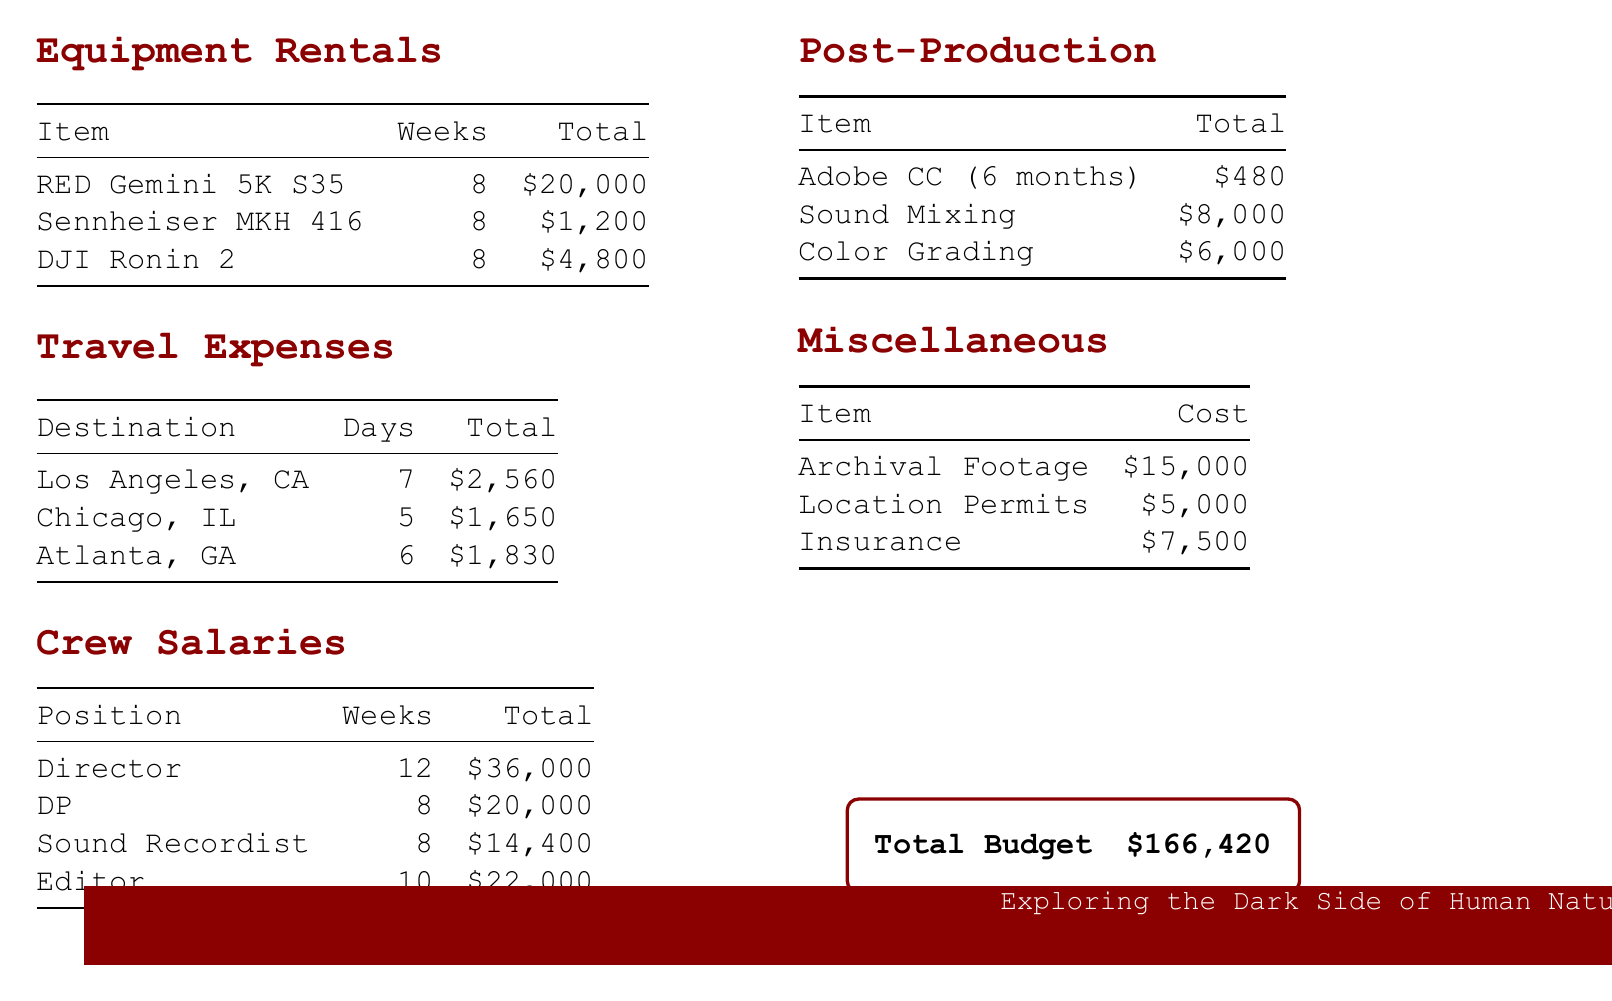what is the total budget? The total budget is located at the bottom of the document, summarizing all costs.
Answer: $166,420 how much does the RED Gemini 5K S35 rental cost? The cost for the RED Gemini 5K S35 is specified in the Equipment Rentals section.
Answer: $20,000 how many days is the trip to Los Angeles, CA? The number of days for the trip to Los Angeles is indicated in the Travel Expenses section.
Answer: 7 who is the Director and how much is their salary? The Director's position and salary are listed under Crew Salaries.
Answer: Director: $36,000 what is the cost of archival footage? The cost of archival footage is presented in the Miscellaneous section.
Answer: $15,000 what is included in post-production costs? The Post-Production section outlines specific items related to post-production expenses.
Answer: Sound Mixing, Color Grading which city has the highest travel expense? This requires comparing the total travel costs for each city listed.
Answer: Los Angeles, CA how many weeks is the Sound Recordist employed for? The employment duration for the Sound Recordist is mentioned in the Crew Salaries section.
Answer: 8 weeks how much is allocated for insurance? The insurance cost can be found in the Miscellaneous section of the budget.
Answer: $7,500 